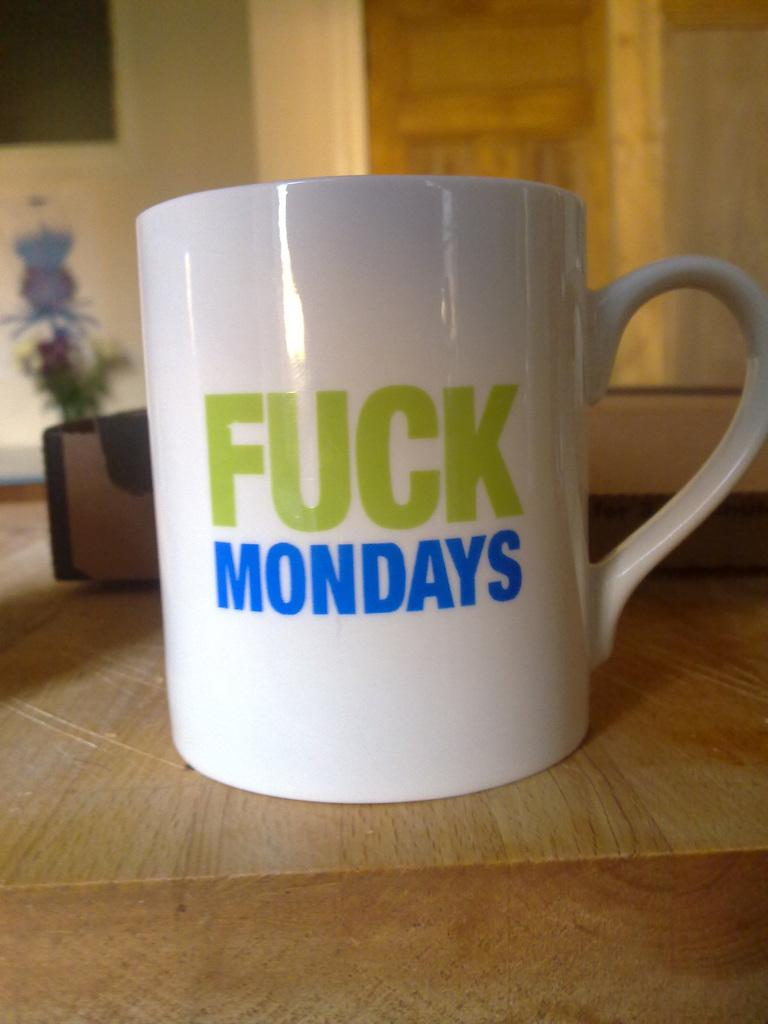What can be seen at the bottom of the image? The ground is visible in the image. What is located on the ground in the image? There are objects on the ground in the image. What is present in the image besides the ground? There is a cup and a wall in the image. Are there any objects attached to the wall in the image? Yes, there are objects attached to the wall in the image. What type of company is represented by the stick in the image? There is no stick present in the image, and therefore no company can be associated with it. 